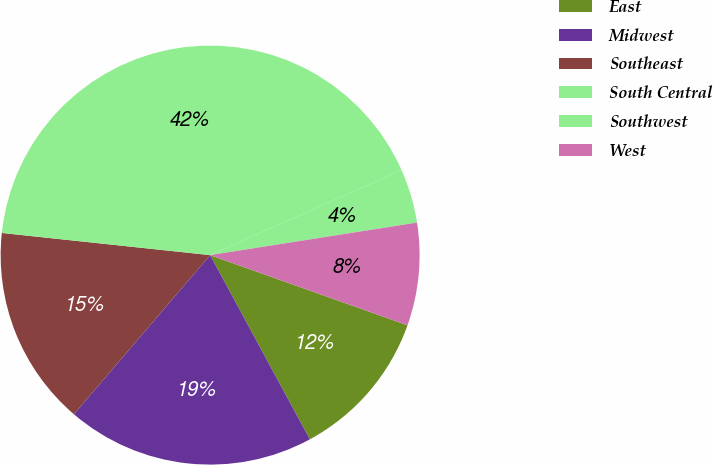<chart> <loc_0><loc_0><loc_500><loc_500><pie_chart><fcel>East<fcel>Midwest<fcel>Southeast<fcel>South Central<fcel>Southwest<fcel>West<nl><fcel>11.67%<fcel>19.17%<fcel>15.42%<fcel>41.67%<fcel>4.17%<fcel>7.92%<nl></chart> 